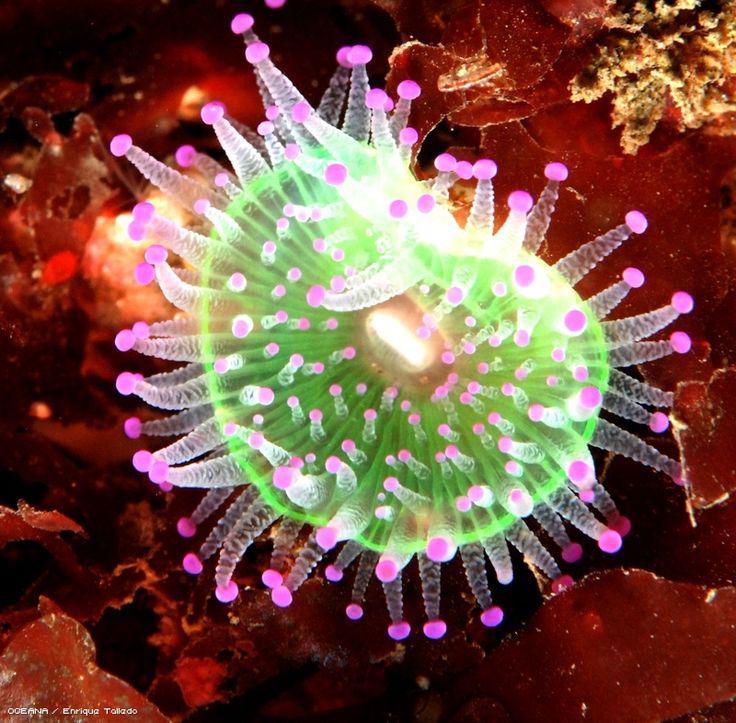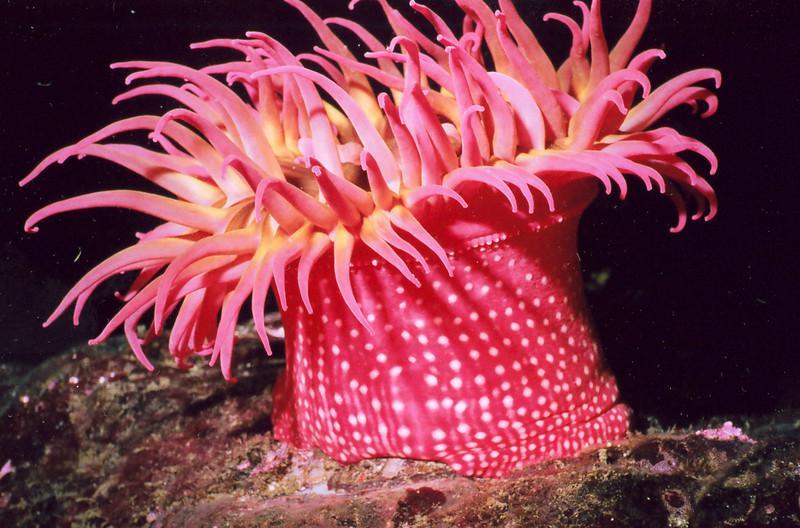The first image is the image on the left, the second image is the image on the right. Assess this claim about the two images: "There are more sea plants in the image on the left than in the image on the right.". Correct or not? Answer yes or no. No. The first image is the image on the left, the second image is the image on the right. For the images shown, is this caption "An image shows the spotted pink stalk of one anemone." true? Answer yes or no. Yes. 